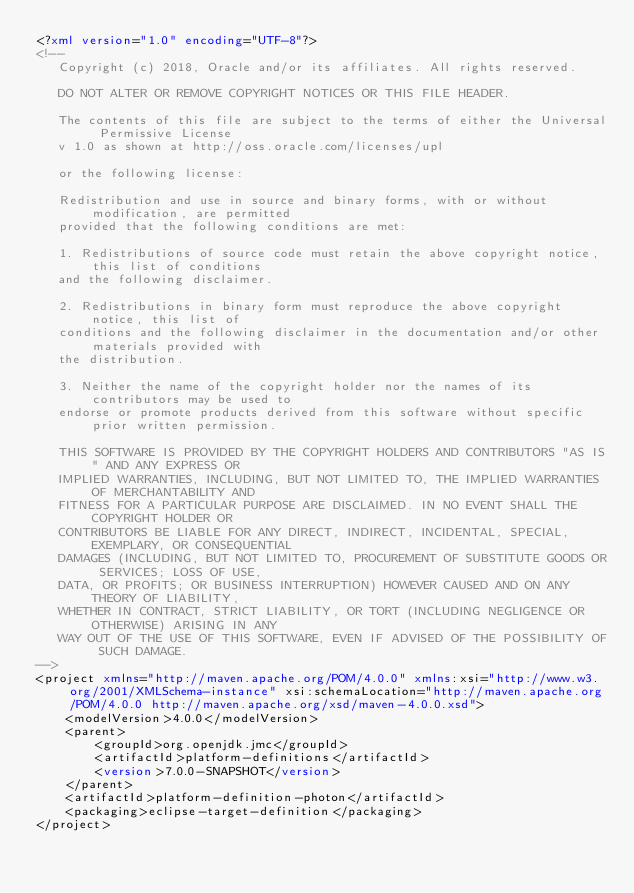<code> <loc_0><loc_0><loc_500><loc_500><_XML_><?xml version="1.0" encoding="UTF-8"?>
<!--   
   Copyright (c) 2018, Oracle and/or its affiliates. All rights reserved.
   
   DO NOT ALTER OR REMOVE COPYRIGHT NOTICES OR THIS FILE HEADER.
   
   The contents of this file are subject to the terms of either the Universal Permissive License 
   v 1.0 as shown at http://oss.oracle.com/licenses/upl
   
   or the following license:
   
   Redistribution and use in source and binary forms, with or without modification, are permitted
   provided that the following conditions are met:
   
   1. Redistributions of source code must retain the above copyright notice, this list of conditions
   and the following disclaimer.
   
   2. Redistributions in binary form must reproduce the above copyright notice, this list of
   conditions and the following disclaimer in the documentation and/or other materials provided with
   the distribution.
   
   3. Neither the name of the copyright holder nor the names of its contributors may be used to
   endorse or promote products derived from this software without specific prior written permission.
   
   THIS SOFTWARE IS PROVIDED BY THE COPYRIGHT HOLDERS AND CONTRIBUTORS "AS IS" AND ANY EXPRESS OR
   IMPLIED WARRANTIES, INCLUDING, BUT NOT LIMITED TO, THE IMPLIED WARRANTIES OF MERCHANTABILITY AND
   FITNESS FOR A PARTICULAR PURPOSE ARE DISCLAIMED. IN NO EVENT SHALL THE COPYRIGHT HOLDER OR
   CONTRIBUTORS BE LIABLE FOR ANY DIRECT, INDIRECT, INCIDENTAL, SPECIAL, EXEMPLARY, OR CONSEQUENTIAL
   DAMAGES (INCLUDING, BUT NOT LIMITED TO, PROCUREMENT OF SUBSTITUTE GOODS OR SERVICES; LOSS OF USE,
   DATA, OR PROFITS; OR BUSINESS INTERRUPTION) HOWEVER CAUSED AND ON ANY THEORY OF LIABILITY,
   WHETHER IN CONTRACT, STRICT LIABILITY, OR TORT (INCLUDING NEGLIGENCE OR OTHERWISE) ARISING IN ANY
   WAY OUT OF THE USE OF THIS SOFTWARE, EVEN IF ADVISED OF THE POSSIBILITY OF SUCH DAMAGE.
-->
<project xmlns="http://maven.apache.org/POM/4.0.0" xmlns:xsi="http://www.w3.org/2001/XMLSchema-instance" xsi:schemaLocation="http://maven.apache.org/POM/4.0.0 http://maven.apache.org/xsd/maven-4.0.0.xsd">
	<modelVersion>4.0.0</modelVersion>
	<parent>
		<groupId>org.openjdk.jmc</groupId>
		<artifactId>platform-definitions</artifactId>
		<version>7.0.0-SNAPSHOT</version>
	</parent>
	<artifactId>platform-definition-photon</artifactId>
	<packaging>eclipse-target-definition</packaging>
</project>
</code> 